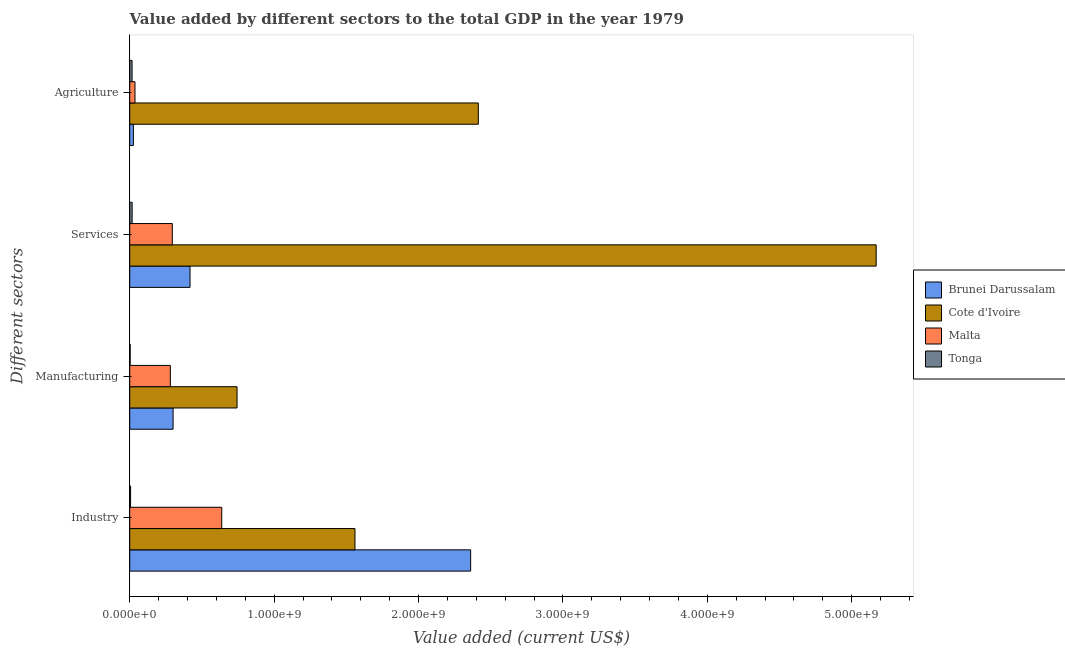How many groups of bars are there?
Offer a very short reply. 4. Are the number of bars on each tick of the Y-axis equal?
Your response must be concise. Yes. How many bars are there on the 1st tick from the top?
Make the answer very short. 4. How many bars are there on the 2nd tick from the bottom?
Provide a short and direct response. 4. What is the label of the 2nd group of bars from the top?
Keep it short and to the point. Services. What is the value added by manufacturing sector in Cote d'Ivoire?
Offer a very short reply. 7.43e+08. Across all countries, what is the maximum value added by agricultural sector?
Ensure brevity in your answer.  2.41e+09. Across all countries, what is the minimum value added by agricultural sector?
Make the answer very short. 1.62e+07. In which country was the value added by manufacturing sector maximum?
Provide a short and direct response. Cote d'Ivoire. In which country was the value added by industrial sector minimum?
Your response must be concise. Tonga. What is the total value added by industrial sector in the graph?
Ensure brevity in your answer.  4.56e+09. What is the difference between the value added by industrial sector in Brunei Darussalam and that in Cote d'Ivoire?
Ensure brevity in your answer.  8.01e+08. What is the difference between the value added by manufacturing sector in Tonga and the value added by services sector in Cote d'Ivoire?
Make the answer very short. -5.17e+09. What is the average value added by services sector per country?
Offer a terse response. 1.47e+09. What is the difference between the value added by services sector and value added by industrial sector in Brunei Darussalam?
Provide a short and direct response. -1.94e+09. What is the ratio of the value added by manufacturing sector in Cote d'Ivoire to that in Malta?
Your answer should be very brief. 2.64. Is the value added by services sector in Brunei Darussalam less than that in Malta?
Make the answer very short. No. What is the difference between the highest and the second highest value added by services sector?
Your answer should be compact. 4.75e+09. What is the difference between the highest and the lowest value added by services sector?
Offer a very short reply. 5.15e+09. What does the 1st bar from the top in Agriculture represents?
Make the answer very short. Tonga. What does the 2nd bar from the bottom in Agriculture represents?
Your answer should be compact. Cote d'Ivoire. Are all the bars in the graph horizontal?
Provide a short and direct response. Yes. What is the difference between two consecutive major ticks on the X-axis?
Ensure brevity in your answer.  1.00e+09. Are the values on the major ticks of X-axis written in scientific E-notation?
Your answer should be very brief. Yes. What is the title of the graph?
Your answer should be compact. Value added by different sectors to the total GDP in the year 1979. Does "Honduras" appear as one of the legend labels in the graph?
Your response must be concise. No. What is the label or title of the X-axis?
Make the answer very short. Value added (current US$). What is the label or title of the Y-axis?
Offer a terse response. Different sectors. What is the Value added (current US$) in Brunei Darussalam in Industry?
Offer a terse response. 2.36e+09. What is the Value added (current US$) in Cote d'Ivoire in Industry?
Your answer should be very brief. 1.56e+09. What is the Value added (current US$) of Malta in Industry?
Keep it short and to the point. 6.37e+08. What is the Value added (current US$) in Tonga in Industry?
Provide a succinct answer. 5.87e+06. What is the Value added (current US$) in Brunei Darussalam in Manufacturing?
Keep it short and to the point. 3.00e+08. What is the Value added (current US$) of Cote d'Ivoire in Manufacturing?
Make the answer very short. 7.43e+08. What is the Value added (current US$) of Malta in Manufacturing?
Your response must be concise. 2.81e+08. What is the Value added (current US$) of Tonga in Manufacturing?
Give a very brief answer. 3.01e+06. What is the Value added (current US$) of Brunei Darussalam in Services?
Ensure brevity in your answer.  4.18e+08. What is the Value added (current US$) in Cote d'Ivoire in Services?
Provide a short and direct response. 5.17e+09. What is the Value added (current US$) of Malta in Services?
Give a very brief answer. 2.95e+08. What is the Value added (current US$) of Tonga in Services?
Make the answer very short. 1.67e+07. What is the Value added (current US$) of Brunei Darussalam in Agriculture?
Ensure brevity in your answer.  2.53e+07. What is the Value added (current US$) in Cote d'Ivoire in Agriculture?
Your answer should be compact. 2.41e+09. What is the Value added (current US$) of Malta in Agriculture?
Offer a very short reply. 3.64e+07. What is the Value added (current US$) in Tonga in Agriculture?
Give a very brief answer. 1.62e+07. Across all Different sectors, what is the maximum Value added (current US$) in Brunei Darussalam?
Offer a terse response. 2.36e+09. Across all Different sectors, what is the maximum Value added (current US$) in Cote d'Ivoire?
Offer a terse response. 5.17e+09. Across all Different sectors, what is the maximum Value added (current US$) in Malta?
Your answer should be compact. 6.37e+08. Across all Different sectors, what is the maximum Value added (current US$) in Tonga?
Your response must be concise. 1.67e+07. Across all Different sectors, what is the minimum Value added (current US$) of Brunei Darussalam?
Offer a very short reply. 2.53e+07. Across all Different sectors, what is the minimum Value added (current US$) in Cote d'Ivoire?
Ensure brevity in your answer.  7.43e+08. Across all Different sectors, what is the minimum Value added (current US$) in Malta?
Give a very brief answer. 3.64e+07. Across all Different sectors, what is the minimum Value added (current US$) of Tonga?
Provide a short and direct response. 3.01e+06. What is the total Value added (current US$) in Brunei Darussalam in the graph?
Keep it short and to the point. 3.10e+09. What is the total Value added (current US$) in Cote d'Ivoire in the graph?
Make the answer very short. 9.89e+09. What is the total Value added (current US$) in Malta in the graph?
Provide a short and direct response. 1.25e+09. What is the total Value added (current US$) of Tonga in the graph?
Your answer should be compact. 4.18e+07. What is the difference between the Value added (current US$) of Brunei Darussalam in Industry and that in Manufacturing?
Offer a terse response. 2.06e+09. What is the difference between the Value added (current US$) of Cote d'Ivoire in Industry and that in Manufacturing?
Keep it short and to the point. 8.17e+08. What is the difference between the Value added (current US$) in Malta in Industry and that in Manufacturing?
Your answer should be compact. 3.56e+08. What is the difference between the Value added (current US$) of Tonga in Industry and that in Manufacturing?
Provide a short and direct response. 2.87e+06. What is the difference between the Value added (current US$) of Brunei Darussalam in Industry and that in Services?
Your answer should be compact. 1.94e+09. What is the difference between the Value added (current US$) of Cote d'Ivoire in Industry and that in Services?
Your response must be concise. -3.61e+09. What is the difference between the Value added (current US$) of Malta in Industry and that in Services?
Offer a terse response. 3.42e+08. What is the difference between the Value added (current US$) of Tonga in Industry and that in Services?
Your answer should be very brief. -1.09e+07. What is the difference between the Value added (current US$) in Brunei Darussalam in Industry and that in Agriculture?
Give a very brief answer. 2.34e+09. What is the difference between the Value added (current US$) of Cote d'Ivoire in Industry and that in Agriculture?
Keep it short and to the point. -8.54e+08. What is the difference between the Value added (current US$) of Malta in Industry and that in Agriculture?
Your answer should be compact. 6.01e+08. What is the difference between the Value added (current US$) of Tonga in Industry and that in Agriculture?
Your answer should be compact. -1.03e+07. What is the difference between the Value added (current US$) of Brunei Darussalam in Manufacturing and that in Services?
Your answer should be very brief. -1.17e+08. What is the difference between the Value added (current US$) of Cote d'Ivoire in Manufacturing and that in Services?
Offer a very short reply. -4.43e+09. What is the difference between the Value added (current US$) in Malta in Manufacturing and that in Services?
Provide a short and direct response. -1.36e+07. What is the difference between the Value added (current US$) in Tonga in Manufacturing and that in Services?
Ensure brevity in your answer.  -1.37e+07. What is the difference between the Value added (current US$) of Brunei Darussalam in Manufacturing and that in Agriculture?
Your response must be concise. 2.75e+08. What is the difference between the Value added (current US$) of Cote d'Ivoire in Manufacturing and that in Agriculture?
Your response must be concise. -1.67e+09. What is the difference between the Value added (current US$) of Malta in Manufacturing and that in Agriculture?
Make the answer very short. 2.45e+08. What is the difference between the Value added (current US$) of Tonga in Manufacturing and that in Agriculture?
Provide a succinct answer. -1.32e+07. What is the difference between the Value added (current US$) in Brunei Darussalam in Services and that in Agriculture?
Ensure brevity in your answer.  3.92e+08. What is the difference between the Value added (current US$) of Cote d'Ivoire in Services and that in Agriculture?
Your response must be concise. 2.76e+09. What is the difference between the Value added (current US$) of Malta in Services and that in Agriculture?
Make the answer very short. 2.59e+08. What is the difference between the Value added (current US$) in Tonga in Services and that in Agriculture?
Your response must be concise. 5.59e+05. What is the difference between the Value added (current US$) in Brunei Darussalam in Industry and the Value added (current US$) in Cote d'Ivoire in Manufacturing?
Your response must be concise. 1.62e+09. What is the difference between the Value added (current US$) of Brunei Darussalam in Industry and the Value added (current US$) of Malta in Manufacturing?
Keep it short and to the point. 2.08e+09. What is the difference between the Value added (current US$) of Brunei Darussalam in Industry and the Value added (current US$) of Tonga in Manufacturing?
Your answer should be very brief. 2.36e+09. What is the difference between the Value added (current US$) of Cote d'Ivoire in Industry and the Value added (current US$) of Malta in Manufacturing?
Your response must be concise. 1.28e+09. What is the difference between the Value added (current US$) of Cote d'Ivoire in Industry and the Value added (current US$) of Tonga in Manufacturing?
Keep it short and to the point. 1.56e+09. What is the difference between the Value added (current US$) in Malta in Industry and the Value added (current US$) in Tonga in Manufacturing?
Ensure brevity in your answer.  6.34e+08. What is the difference between the Value added (current US$) of Brunei Darussalam in Industry and the Value added (current US$) of Cote d'Ivoire in Services?
Make the answer very short. -2.81e+09. What is the difference between the Value added (current US$) in Brunei Darussalam in Industry and the Value added (current US$) in Malta in Services?
Make the answer very short. 2.07e+09. What is the difference between the Value added (current US$) in Brunei Darussalam in Industry and the Value added (current US$) in Tonga in Services?
Provide a succinct answer. 2.34e+09. What is the difference between the Value added (current US$) in Cote d'Ivoire in Industry and the Value added (current US$) in Malta in Services?
Your response must be concise. 1.26e+09. What is the difference between the Value added (current US$) in Cote d'Ivoire in Industry and the Value added (current US$) in Tonga in Services?
Ensure brevity in your answer.  1.54e+09. What is the difference between the Value added (current US$) in Malta in Industry and the Value added (current US$) in Tonga in Services?
Offer a terse response. 6.20e+08. What is the difference between the Value added (current US$) of Brunei Darussalam in Industry and the Value added (current US$) of Cote d'Ivoire in Agriculture?
Provide a succinct answer. -5.31e+07. What is the difference between the Value added (current US$) in Brunei Darussalam in Industry and the Value added (current US$) in Malta in Agriculture?
Make the answer very short. 2.32e+09. What is the difference between the Value added (current US$) of Brunei Darussalam in Industry and the Value added (current US$) of Tonga in Agriculture?
Your answer should be compact. 2.34e+09. What is the difference between the Value added (current US$) of Cote d'Ivoire in Industry and the Value added (current US$) of Malta in Agriculture?
Give a very brief answer. 1.52e+09. What is the difference between the Value added (current US$) in Cote d'Ivoire in Industry and the Value added (current US$) in Tonga in Agriculture?
Provide a succinct answer. 1.54e+09. What is the difference between the Value added (current US$) of Malta in Industry and the Value added (current US$) of Tonga in Agriculture?
Provide a short and direct response. 6.21e+08. What is the difference between the Value added (current US$) in Brunei Darussalam in Manufacturing and the Value added (current US$) in Cote d'Ivoire in Services?
Give a very brief answer. -4.87e+09. What is the difference between the Value added (current US$) of Brunei Darussalam in Manufacturing and the Value added (current US$) of Malta in Services?
Offer a terse response. 5.34e+06. What is the difference between the Value added (current US$) of Brunei Darussalam in Manufacturing and the Value added (current US$) of Tonga in Services?
Your answer should be very brief. 2.84e+08. What is the difference between the Value added (current US$) of Cote d'Ivoire in Manufacturing and the Value added (current US$) of Malta in Services?
Provide a short and direct response. 4.48e+08. What is the difference between the Value added (current US$) in Cote d'Ivoire in Manufacturing and the Value added (current US$) in Tonga in Services?
Your answer should be compact. 7.26e+08. What is the difference between the Value added (current US$) of Malta in Manufacturing and the Value added (current US$) of Tonga in Services?
Your answer should be compact. 2.65e+08. What is the difference between the Value added (current US$) in Brunei Darussalam in Manufacturing and the Value added (current US$) in Cote d'Ivoire in Agriculture?
Provide a short and direct response. -2.11e+09. What is the difference between the Value added (current US$) of Brunei Darussalam in Manufacturing and the Value added (current US$) of Malta in Agriculture?
Your answer should be very brief. 2.64e+08. What is the difference between the Value added (current US$) in Brunei Darussalam in Manufacturing and the Value added (current US$) in Tonga in Agriculture?
Give a very brief answer. 2.84e+08. What is the difference between the Value added (current US$) of Cote d'Ivoire in Manufacturing and the Value added (current US$) of Malta in Agriculture?
Keep it short and to the point. 7.07e+08. What is the difference between the Value added (current US$) in Cote d'Ivoire in Manufacturing and the Value added (current US$) in Tonga in Agriculture?
Provide a short and direct response. 7.27e+08. What is the difference between the Value added (current US$) of Malta in Manufacturing and the Value added (current US$) of Tonga in Agriculture?
Offer a very short reply. 2.65e+08. What is the difference between the Value added (current US$) in Brunei Darussalam in Services and the Value added (current US$) in Cote d'Ivoire in Agriculture?
Provide a succinct answer. -2.00e+09. What is the difference between the Value added (current US$) of Brunei Darussalam in Services and the Value added (current US$) of Malta in Agriculture?
Offer a very short reply. 3.81e+08. What is the difference between the Value added (current US$) of Brunei Darussalam in Services and the Value added (current US$) of Tonga in Agriculture?
Keep it short and to the point. 4.01e+08. What is the difference between the Value added (current US$) of Cote d'Ivoire in Services and the Value added (current US$) of Malta in Agriculture?
Offer a terse response. 5.13e+09. What is the difference between the Value added (current US$) in Cote d'Ivoire in Services and the Value added (current US$) in Tonga in Agriculture?
Give a very brief answer. 5.15e+09. What is the difference between the Value added (current US$) in Malta in Services and the Value added (current US$) in Tonga in Agriculture?
Your response must be concise. 2.79e+08. What is the average Value added (current US$) of Brunei Darussalam per Different sectors?
Your answer should be very brief. 7.76e+08. What is the average Value added (current US$) of Cote d'Ivoire per Different sectors?
Offer a terse response. 2.47e+09. What is the average Value added (current US$) in Malta per Different sectors?
Give a very brief answer. 3.12e+08. What is the average Value added (current US$) in Tonga per Different sectors?
Keep it short and to the point. 1.05e+07. What is the difference between the Value added (current US$) of Brunei Darussalam and Value added (current US$) of Cote d'Ivoire in Industry?
Ensure brevity in your answer.  8.01e+08. What is the difference between the Value added (current US$) in Brunei Darussalam and Value added (current US$) in Malta in Industry?
Your answer should be compact. 1.72e+09. What is the difference between the Value added (current US$) in Brunei Darussalam and Value added (current US$) in Tonga in Industry?
Provide a short and direct response. 2.36e+09. What is the difference between the Value added (current US$) in Cote d'Ivoire and Value added (current US$) in Malta in Industry?
Ensure brevity in your answer.  9.23e+08. What is the difference between the Value added (current US$) in Cote d'Ivoire and Value added (current US$) in Tonga in Industry?
Your answer should be compact. 1.55e+09. What is the difference between the Value added (current US$) of Malta and Value added (current US$) of Tonga in Industry?
Provide a short and direct response. 6.31e+08. What is the difference between the Value added (current US$) in Brunei Darussalam and Value added (current US$) in Cote d'Ivoire in Manufacturing?
Keep it short and to the point. -4.43e+08. What is the difference between the Value added (current US$) of Brunei Darussalam and Value added (current US$) of Malta in Manufacturing?
Your response must be concise. 1.90e+07. What is the difference between the Value added (current US$) of Brunei Darussalam and Value added (current US$) of Tonga in Manufacturing?
Provide a short and direct response. 2.97e+08. What is the difference between the Value added (current US$) of Cote d'Ivoire and Value added (current US$) of Malta in Manufacturing?
Your response must be concise. 4.62e+08. What is the difference between the Value added (current US$) in Cote d'Ivoire and Value added (current US$) in Tonga in Manufacturing?
Offer a terse response. 7.40e+08. What is the difference between the Value added (current US$) of Malta and Value added (current US$) of Tonga in Manufacturing?
Your answer should be compact. 2.78e+08. What is the difference between the Value added (current US$) of Brunei Darussalam and Value added (current US$) of Cote d'Ivoire in Services?
Make the answer very short. -4.75e+09. What is the difference between the Value added (current US$) in Brunei Darussalam and Value added (current US$) in Malta in Services?
Ensure brevity in your answer.  1.23e+08. What is the difference between the Value added (current US$) in Brunei Darussalam and Value added (current US$) in Tonga in Services?
Offer a terse response. 4.01e+08. What is the difference between the Value added (current US$) in Cote d'Ivoire and Value added (current US$) in Malta in Services?
Provide a succinct answer. 4.87e+09. What is the difference between the Value added (current US$) of Cote d'Ivoire and Value added (current US$) of Tonga in Services?
Keep it short and to the point. 5.15e+09. What is the difference between the Value added (current US$) in Malta and Value added (current US$) in Tonga in Services?
Ensure brevity in your answer.  2.78e+08. What is the difference between the Value added (current US$) of Brunei Darussalam and Value added (current US$) of Cote d'Ivoire in Agriculture?
Your response must be concise. -2.39e+09. What is the difference between the Value added (current US$) in Brunei Darussalam and Value added (current US$) in Malta in Agriculture?
Ensure brevity in your answer.  -1.11e+07. What is the difference between the Value added (current US$) in Brunei Darussalam and Value added (current US$) in Tonga in Agriculture?
Make the answer very short. 9.11e+06. What is the difference between the Value added (current US$) in Cote d'Ivoire and Value added (current US$) in Malta in Agriculture?
Your answer should be compact. 2.38e+09. What is the difference between the Value added (current US$) in Cote d'Ivoire and Value added (current US$) in Tonga in Agriculture?
Make the answer very short. 2.40e+09. What is the difference between the Value added (current US$) of Malta and Value added (current US$) of Tonga in Agriculture?
Your response must be concise. 2.02e+07. What is the ratio of the Value added (current US$) in Brunei Darussalam in Industry to that in Manufacturing?
Ensure brevity in your answer.  7.86. What is the ratio of the Value added (current US$) in Cote d'Ivoire in Industry to that in Manufacturing?
Ensure brevity in your answer.  2.1. What is the ratio of the Value added (current US$) of Malta in Industry to that in Manufacturing?
Offer a terse response. 2.27. What is the ratio of the Value added (current US$) of Tonga in Industry to that in Manufacturing?
Offer a very short reply. 1.95. What is the ratio of the Value added (current US$) of Brunei Darussalam in Industry to that in Services?
Provide a succinct answer. 5.65. What is the ratio of the Value added (current US$) in Cote d'Ivoire in Industry to that in Services?
Your answer should be compact. 0.3. What is the ratio of the Value added (current US$) in Malta in Industry to that in Services?
Provide a short and direct response. 2.16. What is the ratio of the Value added (current US$) of Tonga in Industry to that in Services?
Offer a very short reply. 0.35. What is the ratio of the Value added (current US$) of Brunei Darussalam in Industry to that in Agriculture?
Provide a succinct answer. 93.35. What is the ratio of the Value added (current US$) in Cote d'Ivoire in Industry to that in Agriculture?
Provide a short and direct response. 0.65. What is the ratio of the Value added (current US$) of Malta in Industry to that in Agriculture?
Keep it short and to the point. 17.5. What is the ratio of the Value added (current US$) of Tonga in Industry to that in Agriculture?
Provide a succinct answer. 0.36. What is the ratio of the Value added (current US$) of Brunei Darussalam in Manufacturing to that in Services?
Offer a terse response. 0.72. What is the ratio of the Value added (current US$) in Cote d'Ivoire in Manufacturing to that in Services?
Offer a terse response. 0.14. What is the ratio of the Value added (current US$) of Malta in Manufacturing to that in Services?
Your answer should be compact. 0.95. What is the ratio of the Value added (current US$) in Tonga in Manufacturing to that in Services?
Your response must be concise. 0.18. What is the ratio of the Value added (current US$) of Brunei Darussalam in Manufacturing to that in Agriculture?
Your response must be concise. 11.87. What is the ratio of the Value added (current US$) of Cote d'Ivoire in Manufacturing to that in Agriculture?
Make the answer very short. 0.31. What is the ratio of the Value added (current US$) of Malta in Manufacturing to that in Agriculture?
Give a very brief answer. 7.73. What is the ratio of the Value added (current US$) of Tonga in Manufacturing to that in Agriculture?
Provide a short and direct response. 0.19. What is the ratio of the Value added (current US$) in Brunei Darussalam in Services to that in Agriculture?
Your answer should be very brief. 16.51. What is the ratio of the Value added (current US$) of Cote d'Ivoire in Services to that in Agriculture?
Your answer should be compact. 2.14. What is the ratio of the Value added (current US$) of Malta in Services to that in Agriculture?
Offer a terse response. 8.1. What is the ratio of the Value added (current US$) in Tonga in Services to that in Agriculture?
Give a very brief answer. 1.03. What is the difference between the highest and the second highest Value added (current US$) in Brunei Darussalam?
Your response must be concise. 1.94e+09. What is the difference between the highest and the second highest Value added (current US$) of Cote d'Ivoire?
Your answer should be very brief. 2.76e+09. What is the difference between the highest and the second highest Value added (current US$) of Malta?
Make the answer very short. 3.42e+08. What is the difference between the highest and the second highest Value added (current US$) in Tonga?
Provide a succinct answer. 5.59e+05. What is the difference between the highest and the lowest Value added (current US$) in Brunei Darussalam?
Your answer should be very brief. 2.34e+09. What is the difference between the highest and the lowest Value added (current US$) in Cote d'Ivoire?
Offer a terse response. 4.43e+09. What is the difference between the highest and the lowest Value added (current US$) of Malta?
Offer a very short reply. 6.01e+08. What is the difference between the highest and the lowest Value added (current US$) in Tonga?
Your answer should be very brief. 1.37e+07. 